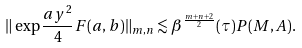Convert formula to latex. <formula><loc_0><loc_0><loc_500><loc_500>\| \exp { \frac { a y ^ { 2 } } { 4 } } F ( a , b ) \| _ { m , n } \lesssim \beta ^ { \frac { m + n + 2 } { 2 } } ( \tau ) P ( M , A ) .</formula> 